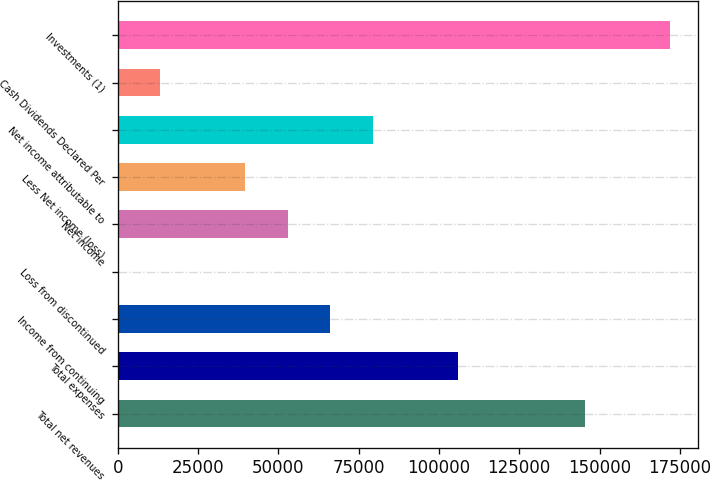Convert chart. <chart><loc_0><loc_0><loc_500><loc_500><bar_chart><fcel>Total net revenues<fcel>Total expenses<fcel>Income from continuing<fcel>Loss from discontinued<fcel>Net income<fcel>Less Net income (loss)<fcel>Net income attributable to<fcel>Cash Dividends Declared Per<fcel>Investments (1)<nl><fcel>145538<fcel>105846<fcel>66153.6<fcel>0.25<fcel>52923<fcel>39692.3<fcel>79384.3<fcel>13230.9<fcel>171999<nl></chart> 